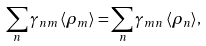<formula> <loc_0><loc_0><loc_500><loc_500>\sum _ { n } \gamma _ { n m } \, \langle \rho _ { m } \rangle = \sum _ { n } \gamma _ { m n } \, \langle \rho _ { n } \rangle ,</formula> 